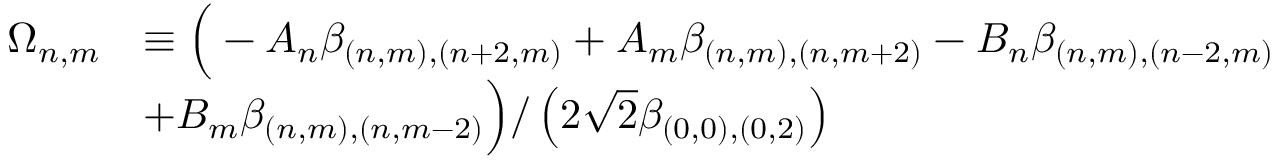<formula> <loc_0><loc_0><loc_500><loc_500>\begin{array} { r l } { \Omega _ { n , m } } & { \equiv \left ( - A _ { n } \beta _ { ( n , m ) , ( n + 2 , m ) } + A _ { m } \beta _ { ( n , m ) , ( n , m + 2 ) } - B _ { n } \beta _ { ( n , m ) , ( n - 2 , m ) } } \\ & { + B _ { m } \beta _ { ( n , m ) , ( n , m - 2 ) } \right ) / \left ( 2 \sqrt { 2 } \beta _ { ( 0 , 0 ) , ( 0 , 2 ) } \right ) } \end{array}</formula> 